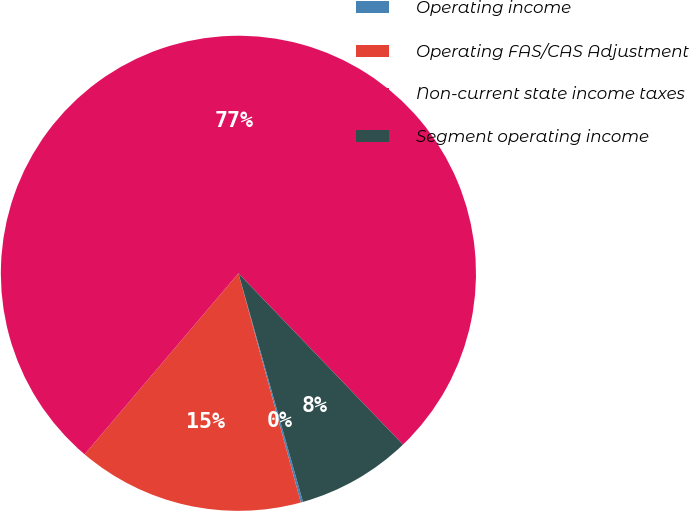Convert chart. <chart><loc_0><loc_0><loc_500><loc_500><pie_chart><fcel>Operating income<fcel>Operating FAS/CAS Adjustment<fcel>Non-current state income taxes<fcel>Segment operating income<nl><fcel>0.15%<fcel>15.44%<fcel>76.6%<fcel>7.8%<nl></chart> 